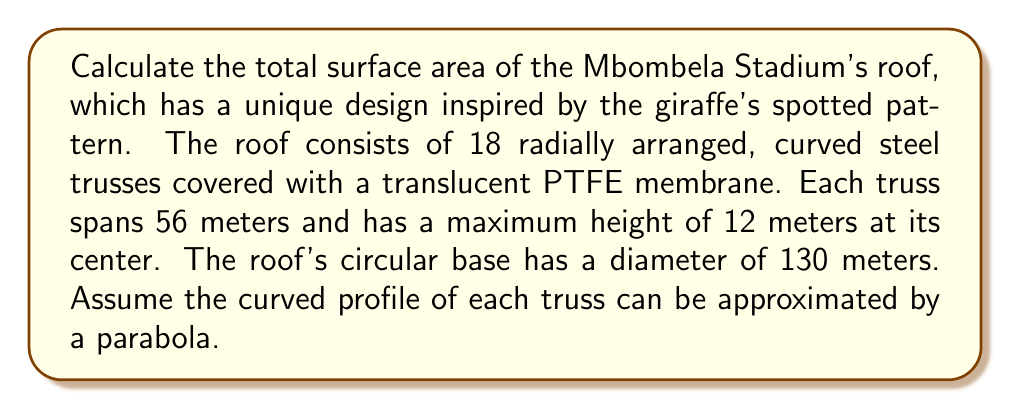Can you answer this question? To solve this problem, we'll follow these steps:

1) First, we need to calculate the area of one truss section:
   
   The truss profile can be modeled as a parabola: $y = ax^2$
   
   Given: 
   - Width (span) = 56 m
   - Height = 12 m
   
   At $x = 28$ (half the span), $y = 12$:
   
   $$12 = a(28)^2$$
   $$a = \frac{12}{784} = \frac{3}{196}$$

   The parabola equation is: $y = \frac{3}{196}x^2$

2) The area under a parabola is given by the formula:
   
   $$A = \int_{-28}^{28} \frac{3}{196}x^2 dx = \frac{3}{196} \cdot \frac{2}{3} \cdot 28^3 = 448 \text{ m}^2$$

3) We need to calculate the arc length of the parabola:
   
   $$L = \int_{-28}^{28} \sqrt{1 + (\frac{dy}{dx})^2} dx = \int_{-28}^{28} \sqrt{1 + (\frac{3}{98}x)^2} dx$$

   This integral doesn't have a simple closed form. Using numerical integration, we get:
   
   $$L \approx 57.3 \text{ m}$$

4) The surface area of one truss section is:
   
   $$A_{truss} = 57.3 \text{ m} \cdot 56 \text{ m} = 3208.8 \text{ m}^2$$

5) There are 18 trusses, so the total surface area of the roof is:
   
   $$A_{total} = 18 \cdot 3208.8 = 57758.4 \text{ m}^2$$

6) We need to subtract the circular base area:
   
   $$A_{base} = \pi r^2 = \pi (65)^2 = 13273.2 \text{ m}^2$$

7) The final surface area is:
   
   $$A_{final} = 57758.4 - 13273.2 = 44485.2 \text{ m}^2$$
Answer: $44485.2 \text{ m}^2$ 